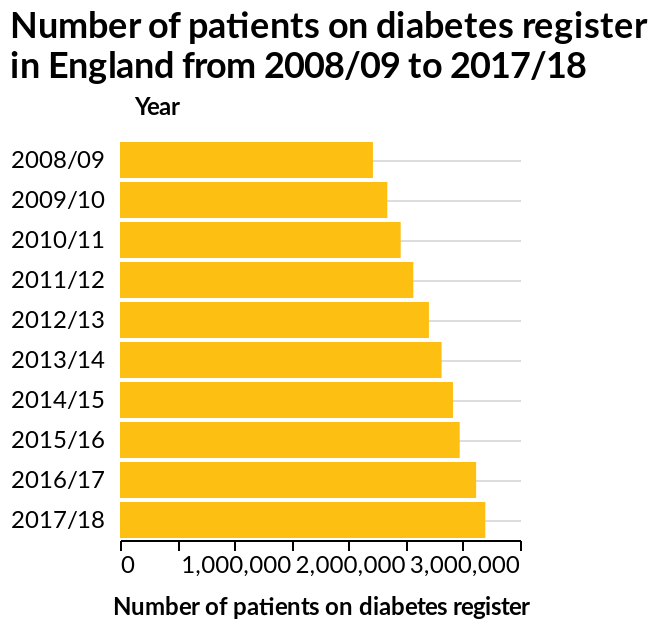<image>
What is the scale used for the y-axis?  The scale used for the y-axis is categorical, representing the years. How is the y-axis labeled in the graph?  The y-axis is labeled with the years ranging from 2008/09 to 2017/18. When was the highest number of patients recorded on the diabetes register? The highest number of patients recorded on the diabetes register was in 2017/18. What is the time period covered by the graph? The graph covers the time period from 2008/09 to 2017/18. 